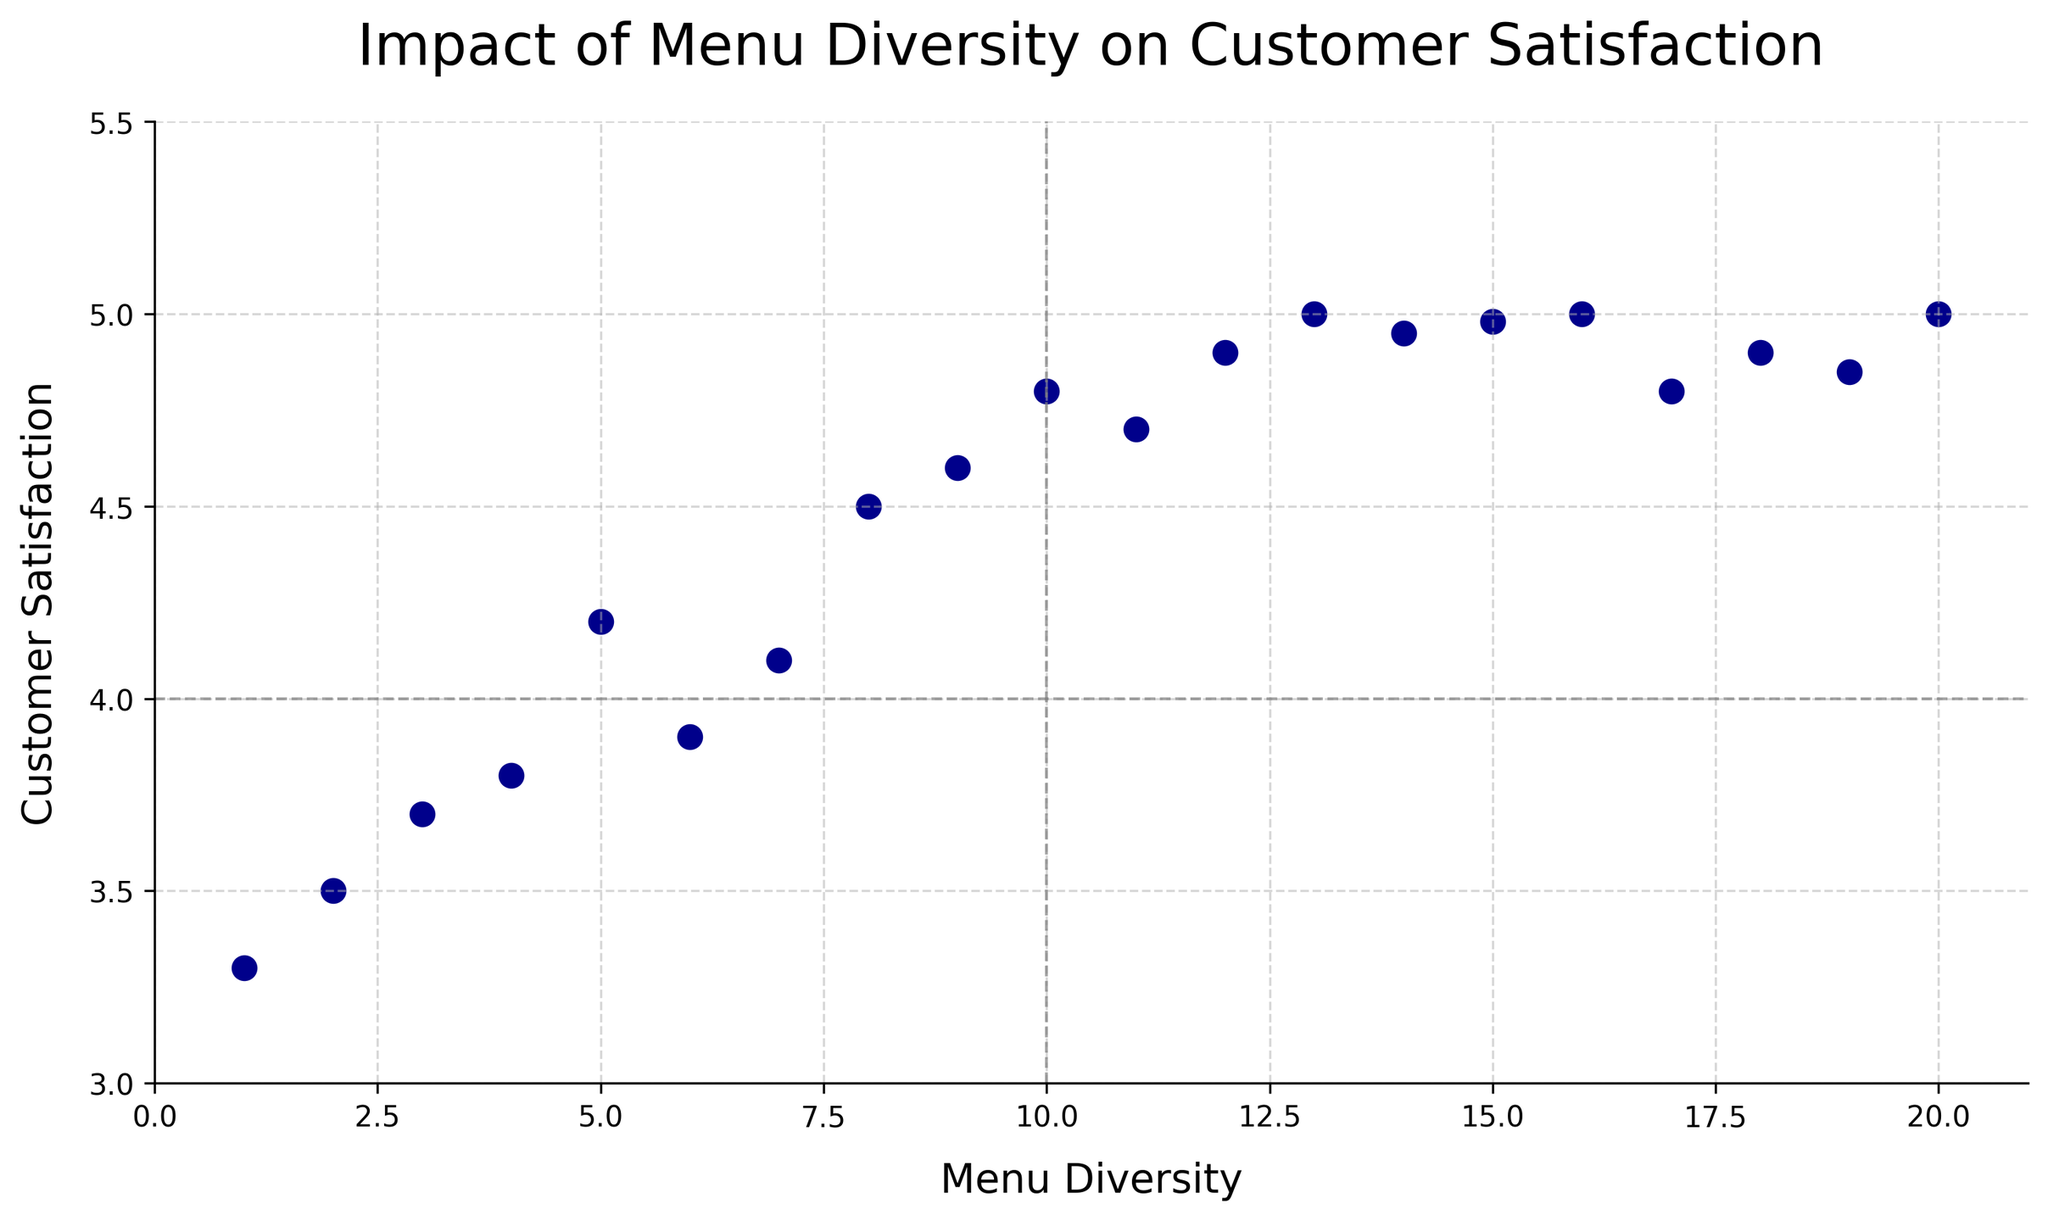What's the average customer satisfaction when menu diversity is less than 8? There are 4 data points with Menu Diversity less than 8 (5, 4, 3, 2, 1) and their respective Customer Satisfaction values are (4.2, 3.8, 3.7, 3.5, 3.3). Summing these values gives 18.5 and dividing by 5 gives 3.7 as the average.
Answer: 3.7 Which Menu Diversity value corresponds to the highest Customer Satisfaction? By looking at the scatter plot, the highest Customer Satisfaction value is 5.0, which corresponds with Menu Diversity values of 13, 16, and 20.
Answer: 13, 16, 20 Is there a trend between Menu Diversity and Customer Satisfaction in the scatter plot? Visually examining the plot shows that as Menu Diversity increases, Customer Satisfaction also generally increases, indicating a positive correlation.
Answer: Yes What is the range of Menu Diversity values plotted? The smallest Menu Diversity value is 1 and the largest value is 20, resulting in a range from 1 to 20.
Answer: 1 to 20 Do any data points lie exactly on the horizontal line y=4? By checking the plot, we see that there are no points with a Customer Satisfaction value exactly equal to 4.
Answer: No For Menu Diversity values 10 and 11, how do their Customer Satisfaction ratings compare? Menu Diversity of 10 corresponds to a Customer Satisfaction of 4.8, and Menu Diversity of 11 corresponds to 4.7. Hence, 10 has a slightly higher rating than 11.
Answer: 10 > 11 What is the Customer Satisfaction value when Menu Diversity is 15? Reviewing the scatter plot, Customer Satisfaction is 4.98 when Menu Diversity is 15.
Answer: 4.98 Are there any outliers or unusual patterns in the plot? Assessing the scatter plot, no points appear significantly distant from the established trend, indicating no clear outliers.
Answer: No How many data points have a Customer Satisfaction value above 4.5? Counting the data points above 4.5 from the plot gives us 8 such points.
Answer: 8 Which point marks the lowest Customer Satisfaction and what is the corresponding Menu Diversity value? The lowest Customer Satisfaction is 3.3, corresponding to a Menu Diversity of 1.
Answer: 1 